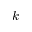Convert formula to latex. <formula><loc_0><loc_0><loc_500><loc_500>k</formula> 